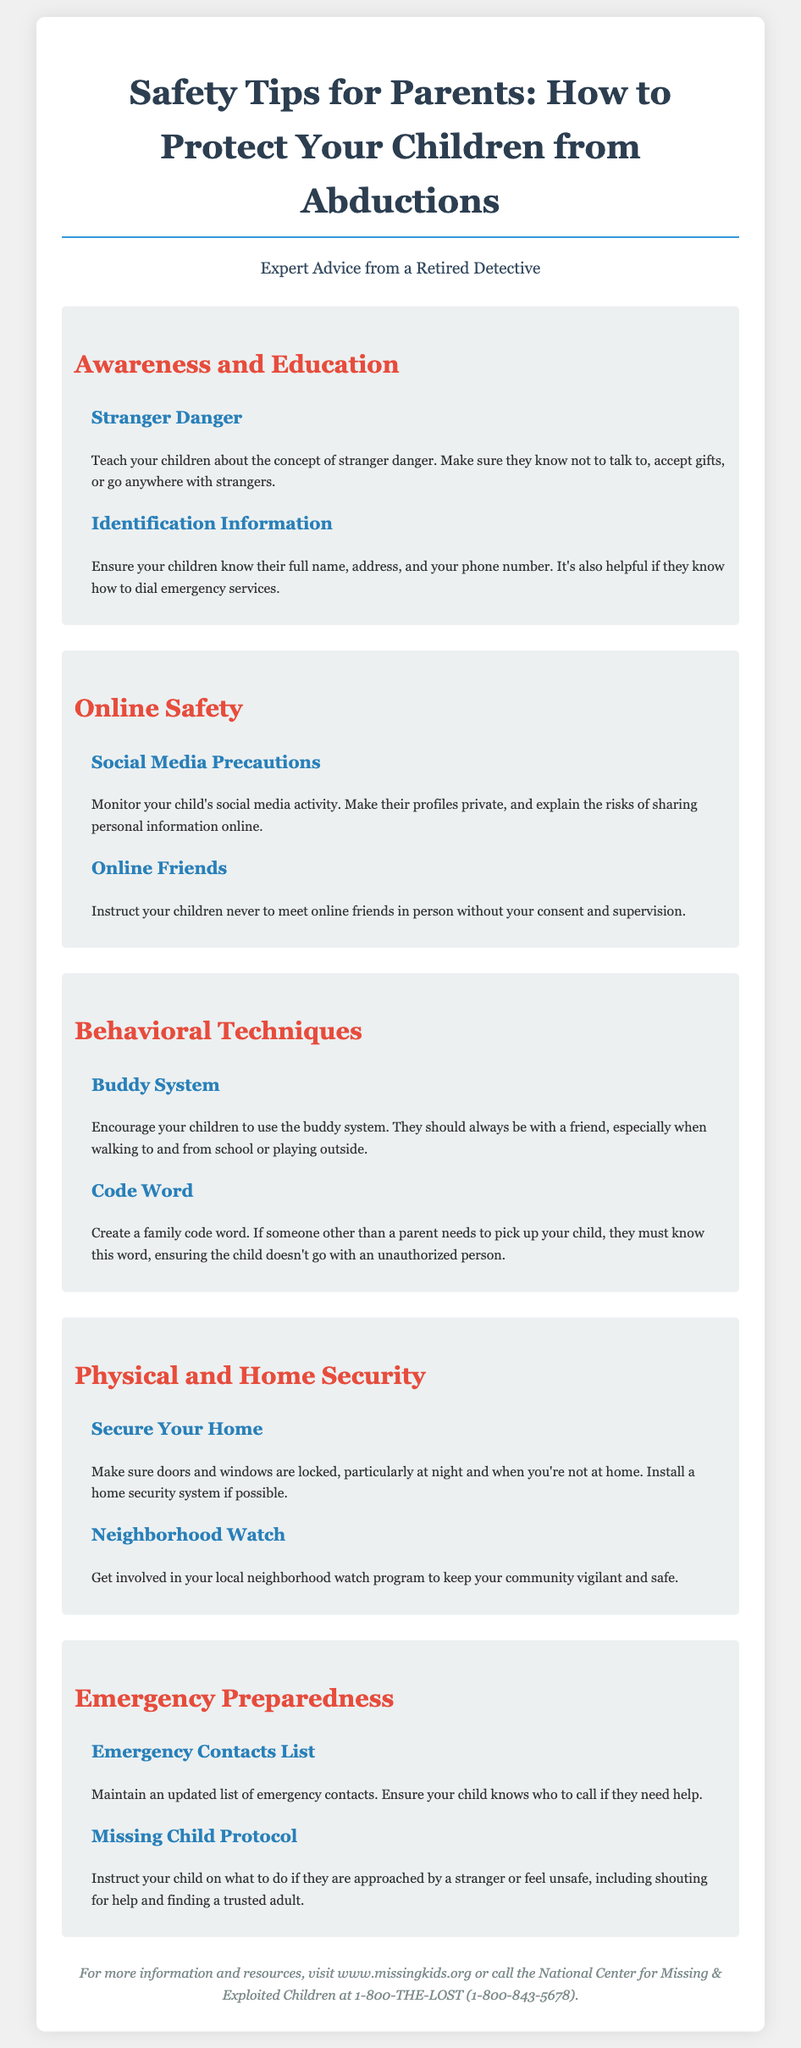What is the title of the flyer? The title summarizes the main topic and purpose of the document, which is about safety tips for parents.
Answer: Safety Tips for Parents: How to Protect Your Children from Abductions What is one tip under "Awareness and Education"? The question focuses on retrieving a specific tip provided in one of the sections of the flyer under the category of Awareness and Education.
Answer: Teach your children about the concept of stranger danger What should children know for identification information? This question aims to gather specific details outlined in the flyer regarding what children should memorize for their safety.
Answer: Their full name, address, and your phone number What does the buddy system encourage? The buddy system is a behavioral technique shared within the document aimed at safety.
Answer: To always be with a friend What is the emergency contacts list for? This question relates to understanding the purpose of the list mentioned in the Emergency Preparedness section.
Answer: Maintaining an updated list of emergency contacts What is suggested to secure your home? The question targets specific actions recommended in the flyer regarding home security.
Answer: Make sure doors and windows are locked What number can you call for the National Center for Missing & Exploited Children? This question retrieves a specific contact number given in the footer of the document for assistance.
Answer: 1-800-THE-LOST (1-800-843-5678) What is one way to enhance neighborhood safety? This requests a method mentioned in the document that involves community involvement for safety.
Answer: Get involved in your local neighborhood watch program 